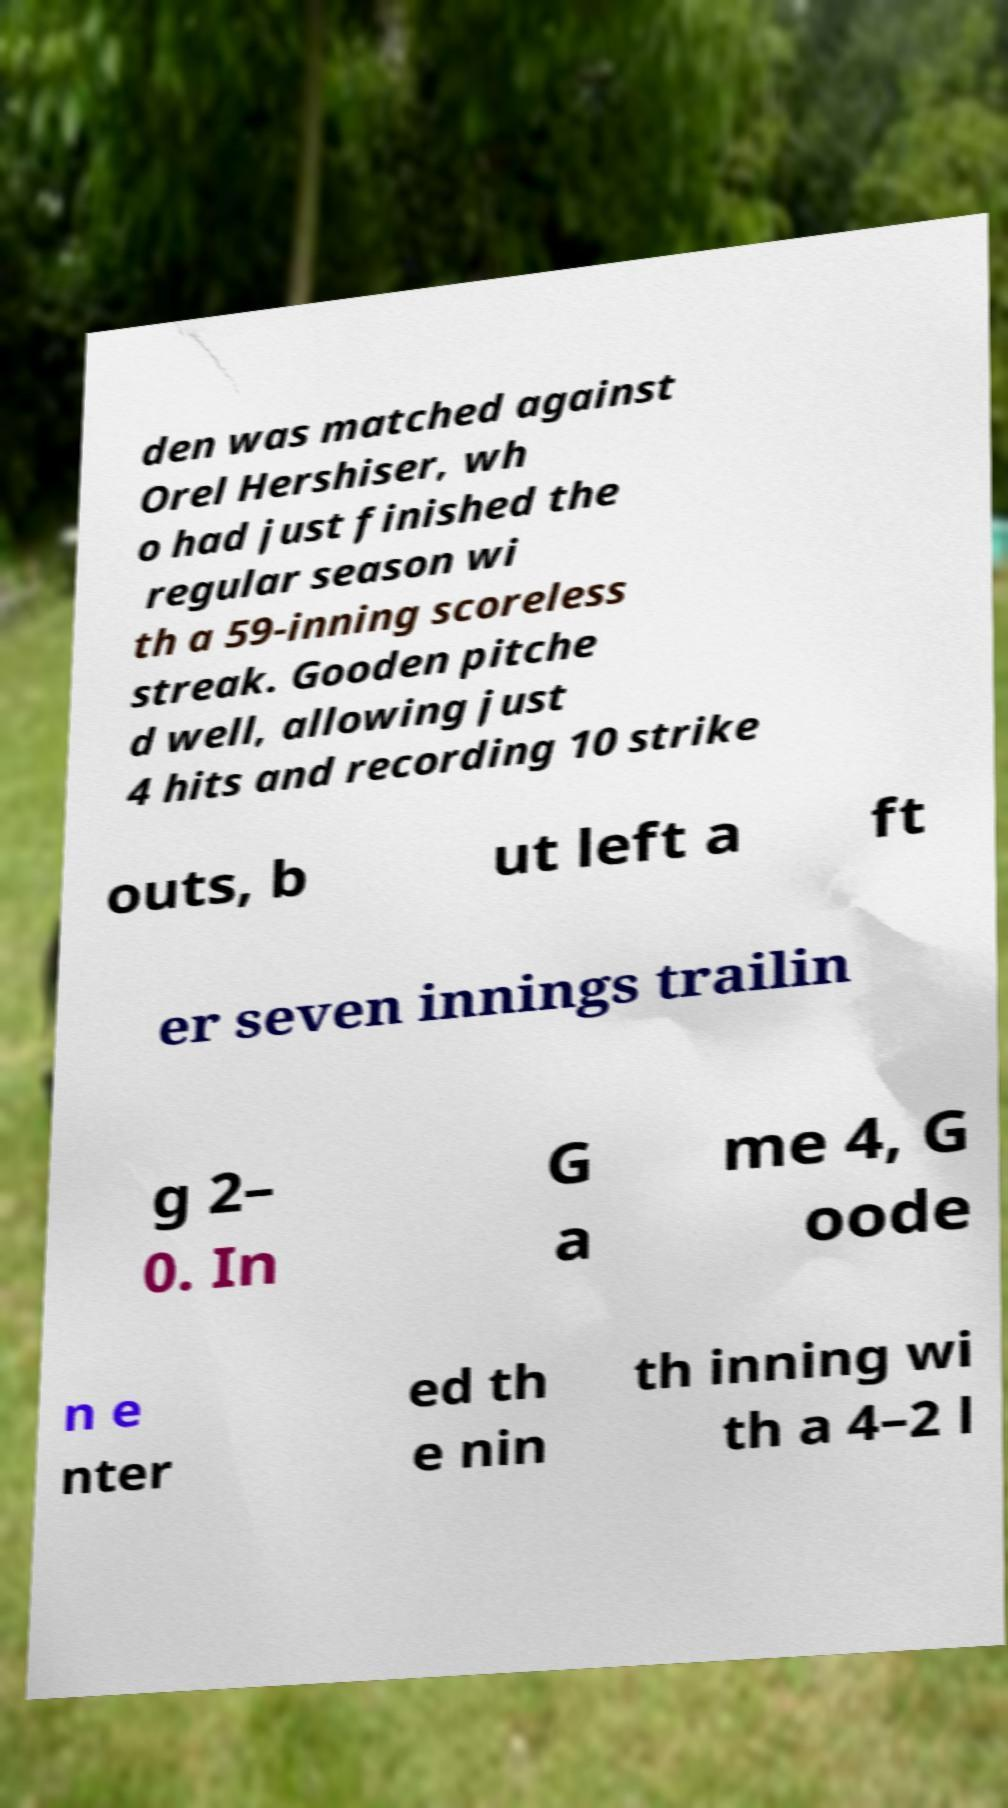Could you assist in decoding the text presented in this image and type it out clearly? den was matched against Orel Hershiser, wh o had just finished the regular season wi th a 59-inning scoreless streak. Gooden pitche d well, allowing just 4 hits and recording 10 strike outs, b ut left a ft er seven innings trailin g 2– 0. In G a me 4, G oode n e nter ed th e nin th inning wi th a 4–2 l 